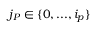<formula> <loc_0><loc_0><loc_500><loc_500>j _ { P } \in \{ 0 , \dots , i _ { p } \}</formula> 